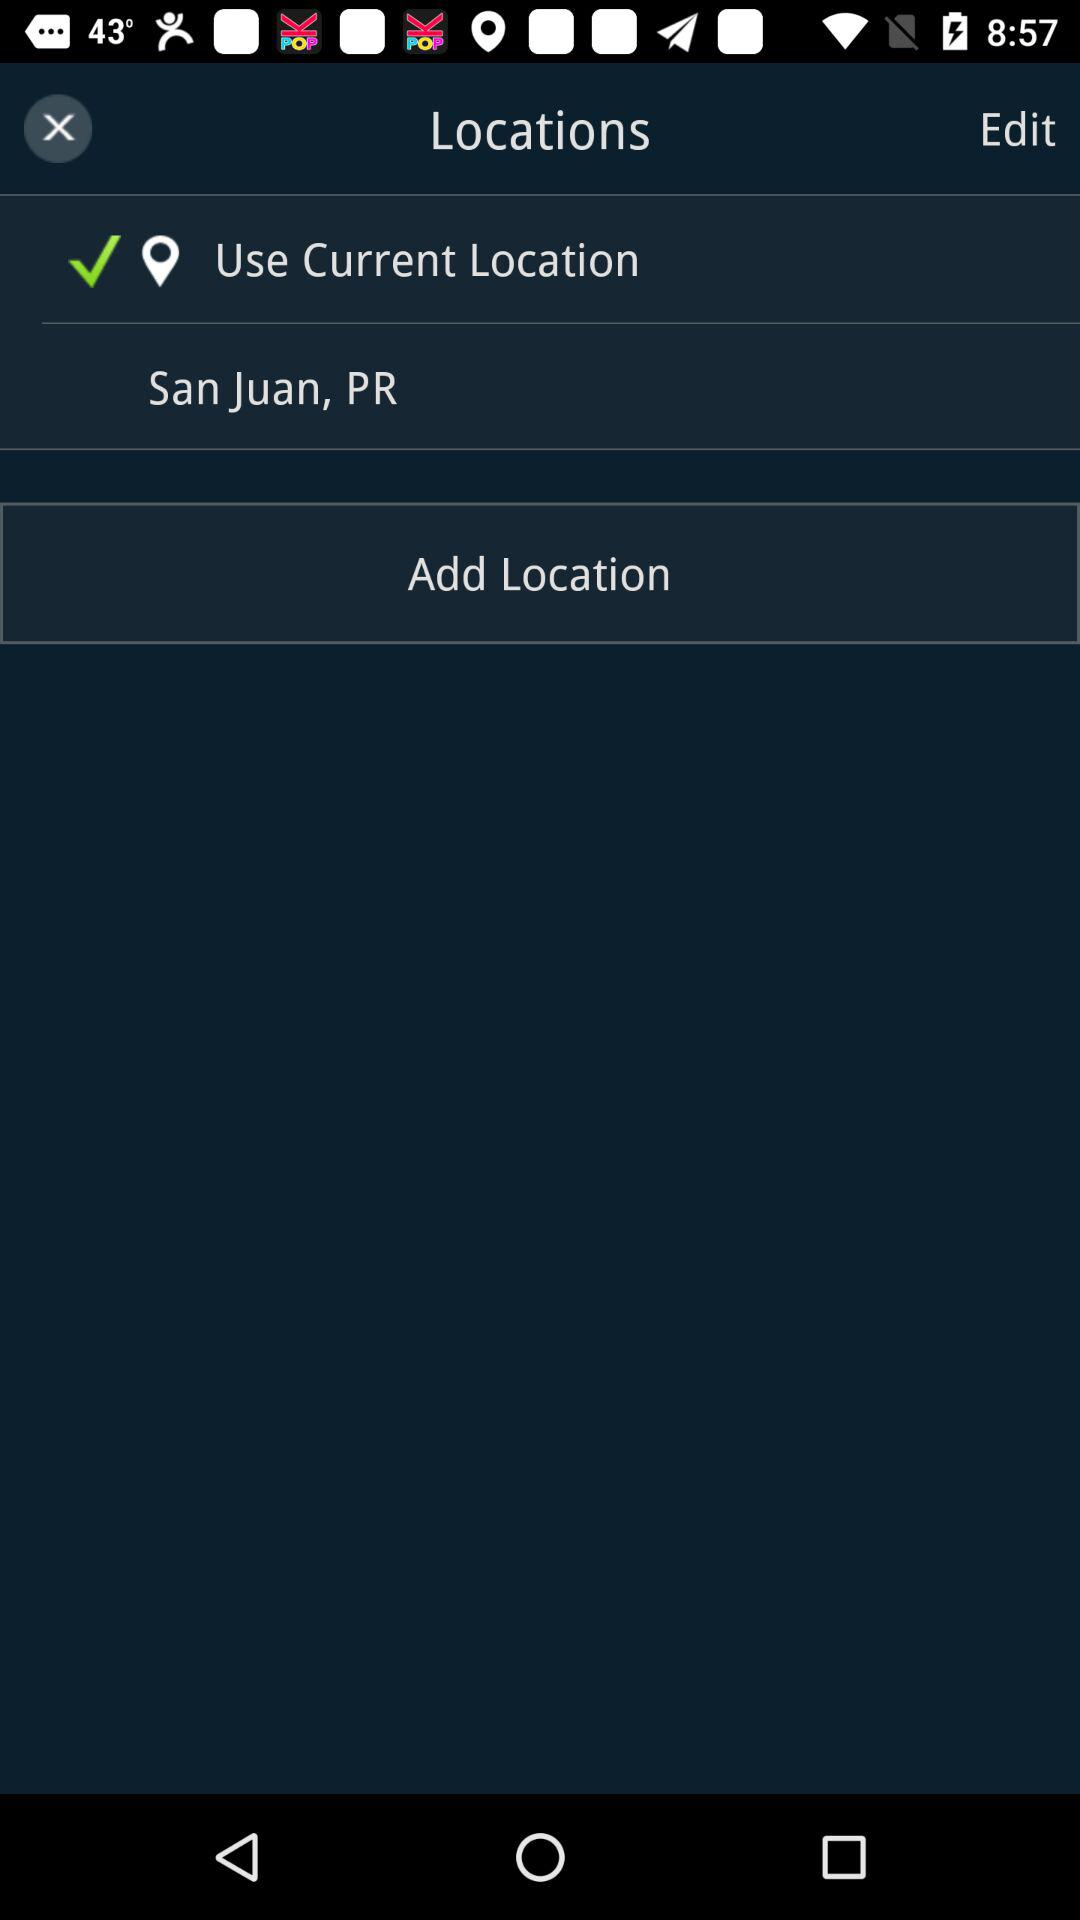How many locations are there?
Answer the question using a single word or phrase. 2 